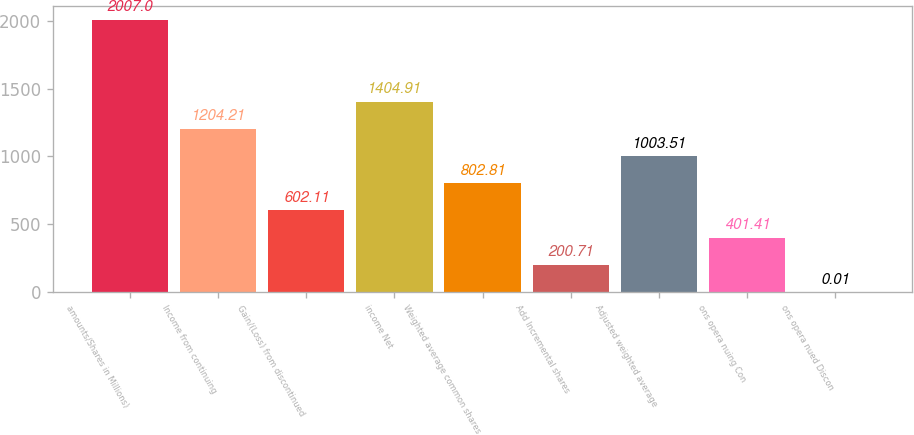<chart> <loc_0><loc_0><loc_500><loc_500><bar_chart><fcel>amounts/Shares in Millions)<fcel>Income from continuing<fcel>Gain/(Loss) from discontinued<fcel>income Net<fcel>Weighted average common shares<fcel>Add Incremental shares<fcel>Adjusted weighted average<fcel>ons opera nuing Con<fcel>ons opera nued Discon<nl><fcel>2007<fcel>1204.21<fcel>602.11<fcel>1404.91<fcel>802.81<fcel>200.71<fcel>1003.51<fcel>401.41<fcel>0.01<nl></chart> 